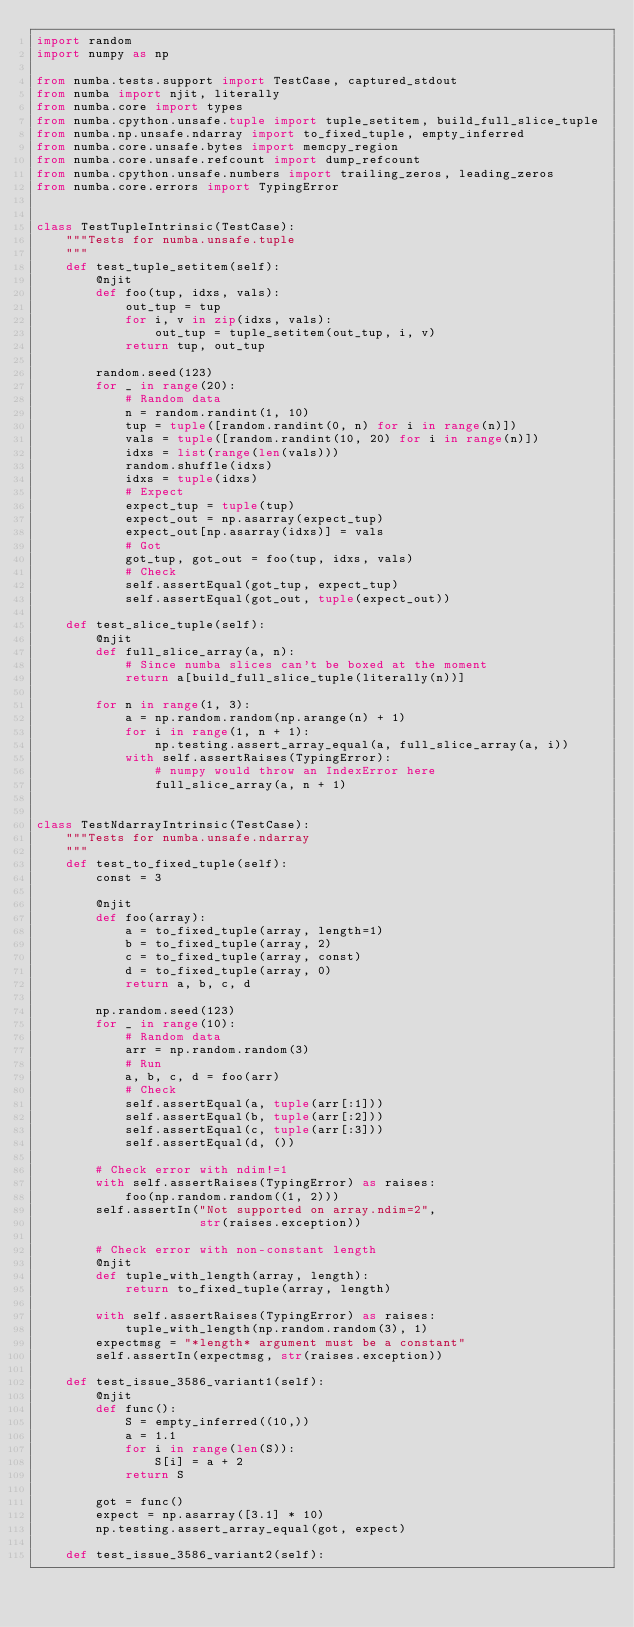Convert code to text. <code><loc_0><loc_0><loc_500><loc_500><_Python_>import random
import numpy as np

from numba.tests.support import TestCase, captured_stdout
from numba import njit, literally
from numba.core import types
from numba.cpython.unsafe.tuple import tuple_setitem, build_full_slice_tuple
from numba.np.unsafe.ndarray import to_fixed_tuple, empty_inferred
from numba.core.unsafe.bytes import memcpy_region
from numba.core.unsafe.refcount import dump_refcount
from numba.cpython.unsafe.numbers import trailing_zeros, leading_zeros
from numba.core.errors import TypingError


class TestTupleIntrinsic(TestCase):
    """Tests for numba.unsafe.tuple
    """
    def test_tuple_setitem(self):
        @njit
        def foo(tup, idxs, vals):
            out_tup = tup
            for i, v in zip(idxs, vals):
                out_tup = tuple_setitem(out_tup, i, v)
            return tup, out_tup

        random.seed(123)
        for _ in range(20):
            # Random data
            n = random.randint(1, 10)
            tup = tuple([random.randint(0, n) for i in range(n)])
            vals = tuple([random.randint(10, 20) for i in range(n)])
            idxs = list(range(len(vals)))
            random.shuffle(idxs)
            idxs = tuple(idxs)
            # Expect
            expect_tup = tuple(tup)
            expect_out = np.asarray(expect_tup)
            expect_out[np.asarray(idxs)] = vals
            # Got
            got_tup, got_out = foo(tup, idxs, vals)
            # Check
            self.assertEqual(got_tup, expect_tup)
            self.assertEqual(got_out, tuple(expect_out))

    def test_slice_tuple(self):
        @njit
        def full_slice_array(a, n):
            # Since numba slices can't be boxed at the moment
            return a[build_full_slice_tuple(literally(n))]

        for n in range(1, 3):
            a = np.random.random(np.arange(n) + 1)
            for i in range(1, n + 1):
                np.testing.assert_array_equal(a, full_slice_array(a, i))
            with self.assertRaises(TypingError):
                # numpy would throw an IndexError here
                full_slice_array(a, n + 1)


class TestNdarrayIntrinsic(TestCase):
    """Tests for numba.unsafe.ndarray
    """
    def test_to_fixed_tuple(self):
        const = 3

        @njit
        def foo(array):
            a = to_fixed_tuple(array, length=1)
            b = to_fixed_tuple(array, 2)
            c = to_fixed_tuple(array, const)
            d = to_fixed_tuple(array, 0)
            return a, b, c, d

        np.random.seed(123)
        for _ in range(10):
            # Random data
            arr = np.random.random(3)
            # Run
            a, b, c, d = foo(arr)
            # Check
            self.assertEqual(a, tuple(arr[:1]))
            self.assertEqual(b, tuple(arr[:2]))
            self.assertEqual(c, tuple(arr[:3]))
            self.assertEqual(d, ())

        # Check error with ndim!=1
        with self.assertRaises(TypingError) as raises:
            foo(np.random.random((1, 2)))
        self.assertIn("Not supported on array.ndim=2",
                      str(raises.exception))

        # Check error with non-constant length
        @njit
        def tuple_with_length(array, length):
            return to_fixed_tuple(array, length)

        with self.assertRaises(TypingError) as raises:
            tuple_with_length(np.random.random(3), 1)
        expectmsg = "*length* argument must be a constant"
        self.assertIn(expectmsg, str(raises.exception))

    def test_issue_3586_variant1(self):
        @njit
        def func():
            S = empty_inferred((10,))
            a = 1.1
            for i in range(len(S)):
                S[i] = a + 2
            return S

        got = func()
        expect = np.asarray([3.1] * 10)
        np.testing.assert_array_equal(got, expect)

    def test_issue_3586_variant2(self):</code> 